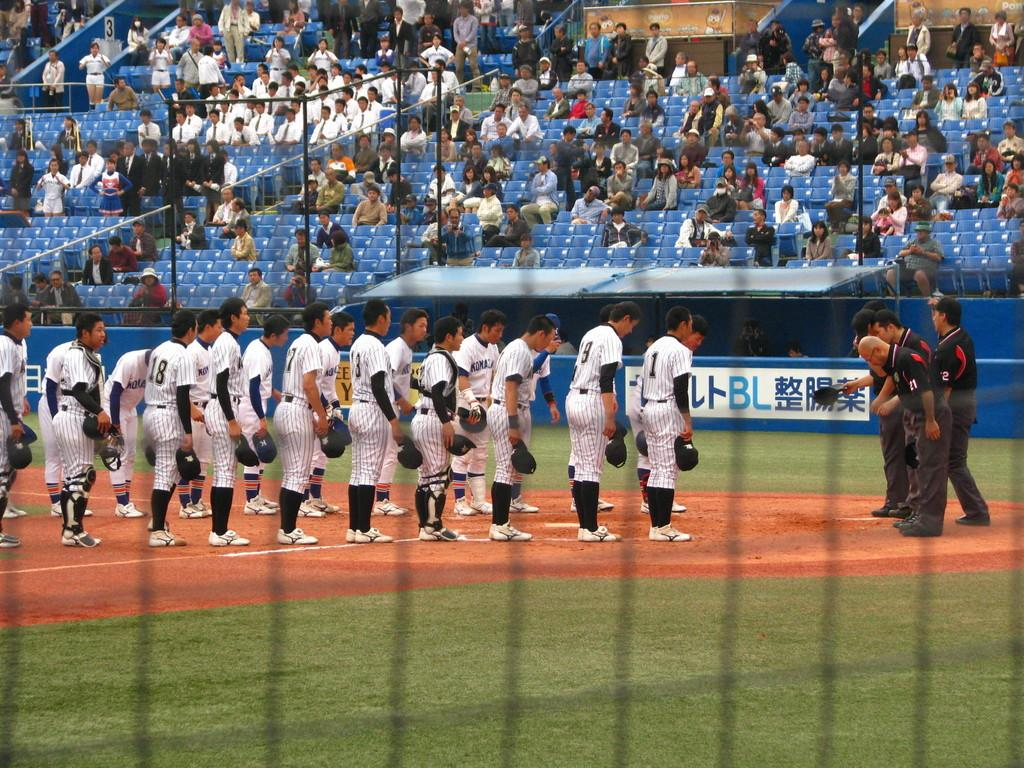<image>
Render a clear and concise summary of the photo. The baseball players are standing on the field including ones with #18 and #1 on their uniforms. 